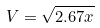Convert formula to latex. <formula><loc_0><loc_0><loc_500><loc_500>V = \sqrt { 2 . 6 7 x }</formula> 